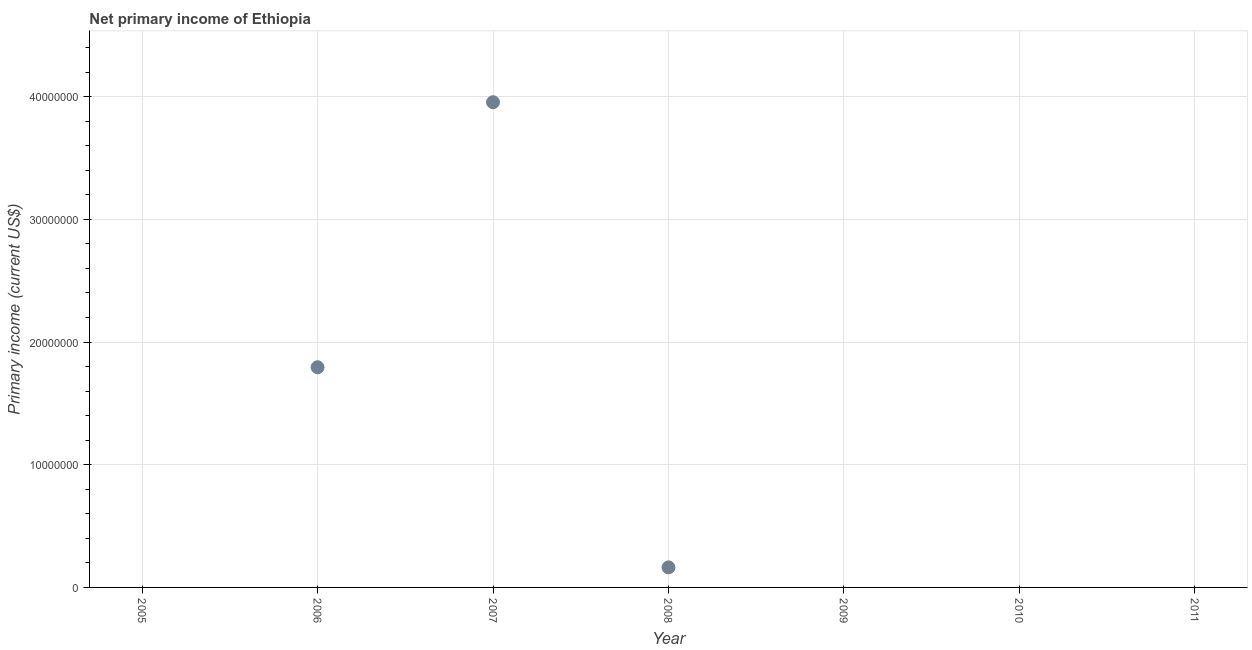What is the amount of primary income in 2007?
Your answer should be very brief. 3.95e+07. Across all years, what is the maximum amount of primary income?
Make the answer very short. 3.95e+07. What is the sum of the amount of primary income?
Your answer should be compact. 5.91e+07. What is the difference between the amount of primary income in 2006 and 2007?
Provide a succinct answer. -2.16e+07. What is the average amount of primary income per year?
Provide a short and direct response. 8.45e+06. What is the median amount of primary income?
Ensure brevity in your answer.  0. Is the difference between the amount of primary income in 2006 and 2007 greater than the difference between any two years?
Your response must be concise. No. What is the difference between the highest and the second highest amount of primary income?
Ensure brevity in your answer.  2.16e+07. What is the difference between the highest and the lowest amount of primary income?
Make the answer very short. 3.95e+07. In how many years, is the amount of primary income greater than the average amount of primary income taken over all years?
Your response must be concise. 2. How many dotlines are there?
Provide a short and direct response. 1. How many years are there in the graph?
Offer a very short reply. 7. Are the values on the major ticks of Y-axis written in scientific E-notation?
Ensure brevity in your answer.  No. Does the graph contain grids?
Provide a succinct answer. Yes. What is the title of the graph?
Provide a short and direct response. Net primary income of Ethiopia. What is the label or title of the Y-axis?
Your answer should be compact. Primary income (current US$). What is the Primary income (current US$) in 2006?
Your answer should be very brief. 1.79e+07. What is the Primary income (current US$) in 2007?
Your answer should be compact. 3.95e+07. What is the Primary income (current US$) in 2008?
Give a very brief answer. 1.63e+06. What is the Primary income (current US$) in 2009?
Your response must be concise. 0. What is the difference between the Primary income (current US$) in 2006 and 2007?
Give a very brief answer. -2.16e+07. What is the difference between the Primary income (current US$) in 2006 and 2008?
Provide a short and direct response. 1.63e+07. What is the difference between the Primary income (current US$) in 2007 and 2008?
Your response must be concise. 3.79e+07. What is the ratio of the Primary income (current US$) in 2006 to that in 2007?
Your answer should be very brief. 0.45. What is the ratio of the Primary income (current US$) in 2006 to that in 2008?
Ensure brevity in your answer.  10.98. What is the ratio of the Primary income (current US$) in 2007 to that in 2008?
Your answer should be very brief. 24.19. 